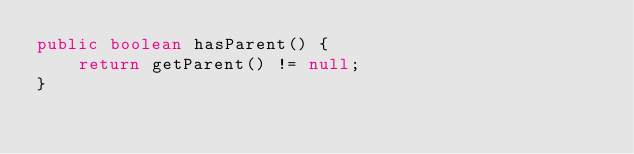<code> <loc_0><loc_0><loc_500><loc_500><_Java_>public boolean hasParent() {
    return getParent() != null;
}</code> 